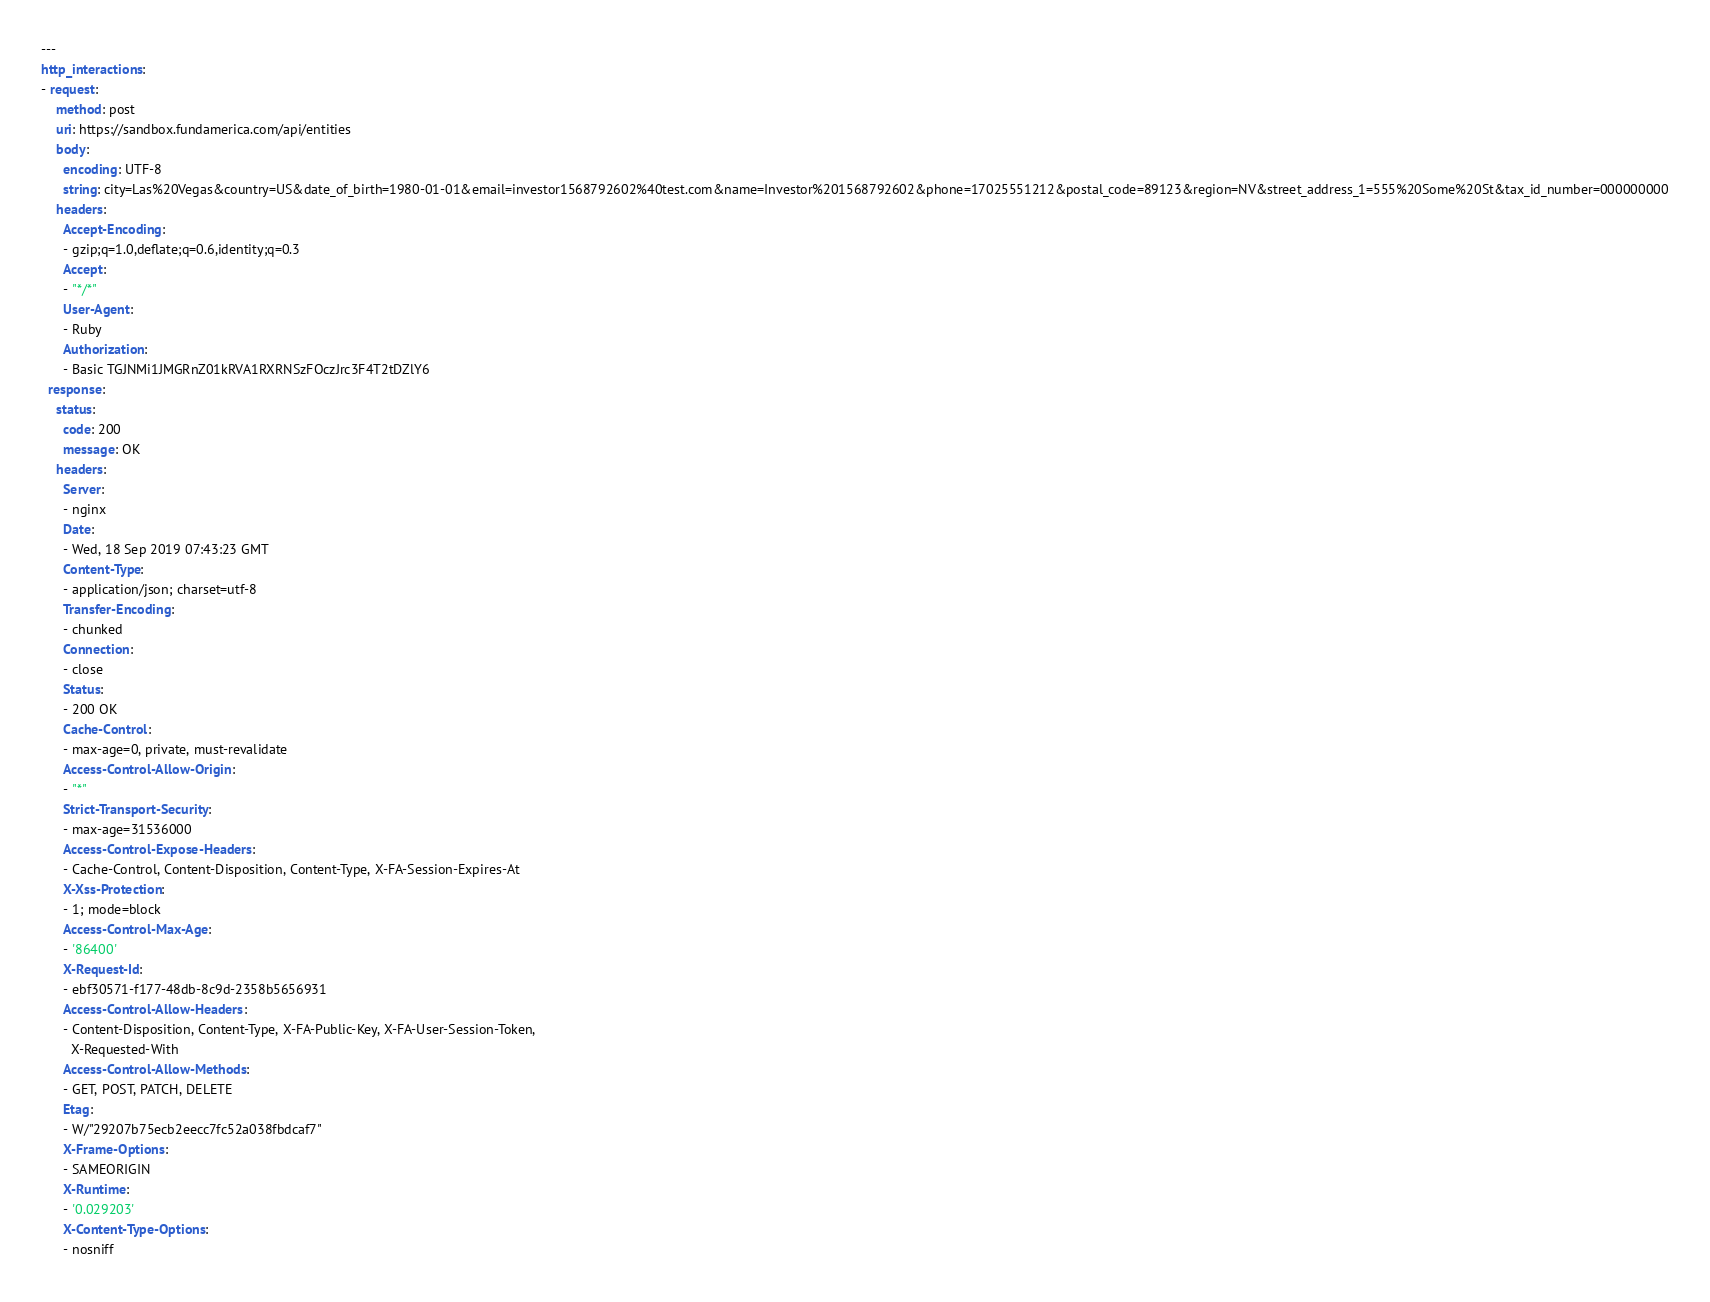<code> <loc_0><loc_0><loc_500><loc_500><_YAML_>---
http_interactions:
- request:
    method: post
    uri: https://sandbox.fundamerica.com/api/entities
    body:
      encoding: UTF-8
      string: city=Las%20Vegas&country=US&date_of_birth=1980-01-01&email=investor1568792602%40test.com&name=Investor%201568792602&phone=17025551212&postal_code=89123&region=NV&street_address_1=555%20Some%20St&tax_id_number=000000000
    headers:
      Accept-Encoding:
      - gzip;q=1.0,deflate;q=0.6,identity;q=0.3
      Accept:
      - "*/*"
      User-Agent:
      - Ruby
      Authorization:
      - Basic TGJNMi1JMGRnZ01kRVA1RXRNSzFOczJrc3F4T2tDZlY6
  response:
    status:
      code: 200
      message: OK
    headers:
      Server:
      - nginx
      Date:
      - Wed, 18 Sep 2019 07:43:23 GMT
      Content-Type:
      - application/json; charset=utf-8
      Transfer-Encoding:
      - chunked
      Connection:
      - close
      Status:
      - 200 OK
      Cache-Control:
      - max-age=0, private, must-revalidate
      Access-Control-Allow-Origin:
      - "*"
      Strict-Transport-Security:
      - max-age=31536000
      Access-Control-Expose-Headers:
      - Cache-Control, Content-Disposition, Content-Type, X-FA-Session-Expires-At
      X-Xss-Protection:
      - 1; mode=block
      Access-Control-Max-Age:
      - '86400'
      X-Request-Id:
      - ebf30571-f177-48db-8c9d-2358b5656931
      Access-Control-Allow-Headers:
      - Content-Disposition, Content-Type, X-FA-Public-Key, X-FA-User-Session-Token,
        X-Requested-With
      Access-Control-Allow-Methods:
      - GET, POST, PATCH, DELETE
      Etag:
      - W/"29207b75ecb2eecc7fc52a038fbdcaf7"
      X-Frame-Options:
      - SAMEORIGIN
      X-Runtime:
      - '0.029203'
      X-Content-Type-Options:
      - nosniff</code> 